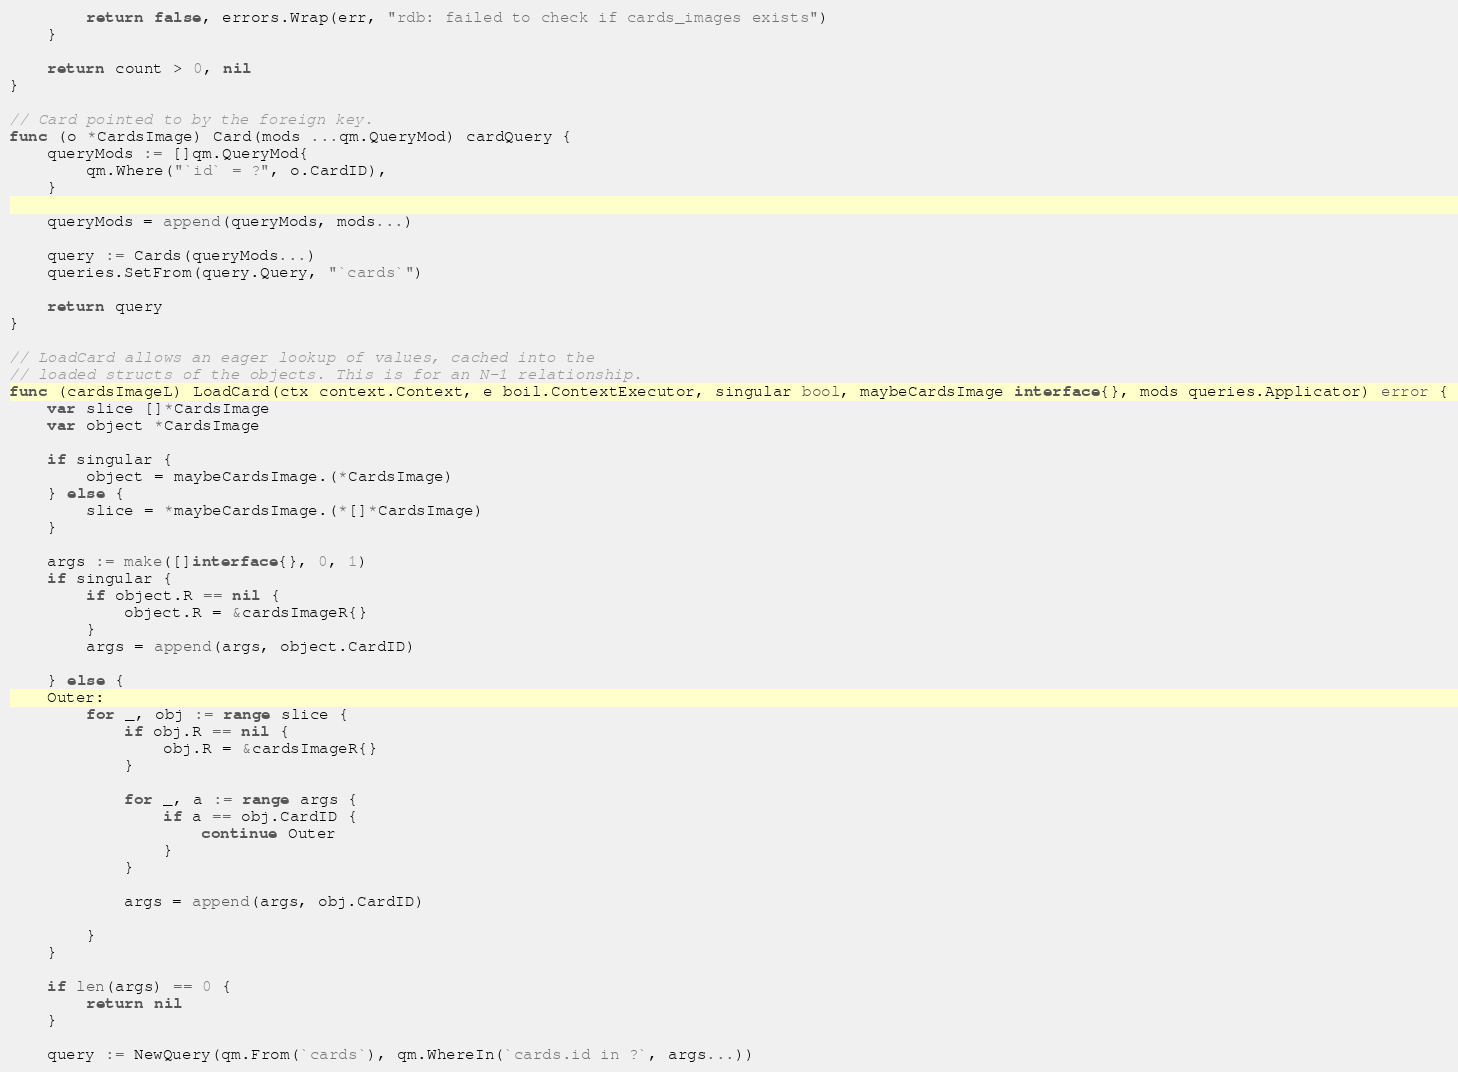Convert code to text. <code><loc_0><loc_0><loc_500><loc_500><_Go_>		return false, errors.Wrap(err, "rdb: failed to check if cards_images exists")
	}

	return count > 0, nil
}

// Card pointed to by the foreign key.
func (o *CardsImage) Card(mods ...qm.QueryMod) cardQuery {
	queryMods := []qm.QueryMod{
		qm.Where("`id` = ?", o.CardID),
	}

	queryMods = append(queryMods, mods...)

	query := Cards(queryMods...)
	queries.SetFrom(query.Query, "`cards`")

	return query
}

// LoadCard allows an eager lookup of values, cached into the
// loaded structs of the objects. This is for an N-1 relationship.
func (cardsImageL) LoadCard(ctx context.Context, e boil.ContextExecutor, singular bool, maybeCardsImage interface{}, mods queries.Applicator) error {
	var slice []*CardsImage
	var object *CardsImage

	if singular {
		object = maybeCardsImage.(*CardsImage)
	} else {
		slice = *maybeCardsImage.(*[]*CardsImage)
	}

	args := make([]interface{}, 0, 1)
	if singular {
		if object.R == nil {
			object.R = &cardsImageR{}
		}
		args = append(args, object.CardID)

	} else {
	Outer:
		for _, obj := range slice {
			if obj.R == nil {
				obj.R = &cardsImageR{}
			}

			for _, a := range args {
				if a == obj.CardID {
					continue Outer
				}
			}

			args = append(args, obj.CardID)

		}
	}

	if len(args) == 0 {
		return nil
	}

	query := NewQuery(qm.From(`cards`), qm.WhereIn(`cards.id in ?`, args...))</code> 